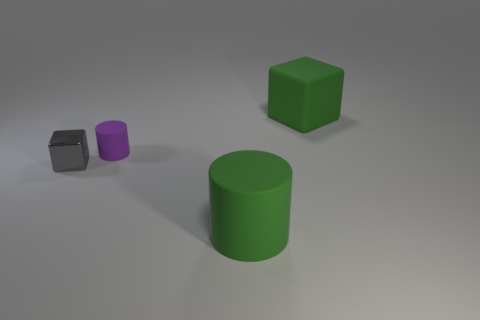Is there anything else that has the same material as the gray block?
Your answer should be compact. No. Are there more large green rubber cylinders on the left side of the small purple thing than small gray metallic things?
Offer a terse response. No. How many tiny things are right of the rubber thing behind the tiny cylinder?
Your answer should be compact. 0. The thing that is to the right of the green matte object that is in front of the block behind the tiny matte cylinder is what shape?
Provide a short and direct response. Cube. What is the size of the shiny cube?
Make the answer very short. Small. Is there a large blue ball made of the same material as the small cube?
Provide a succinct answer. No. The green rubber thing that is the same shape as the small purple thing is what size?
Your response must be concise. Large. Are there the same number of big green blocks on the right side of the purple rubber object and big shiny spheres?
Keep it short and to the point. No. Do the rubber object that is in front of the small gray cube and the purple matte object have the same shape?
Make the answer very short. Yes. There is a tiny purple rubber thing; what shape is it?
Keep it short and to the point. Cylinder. 